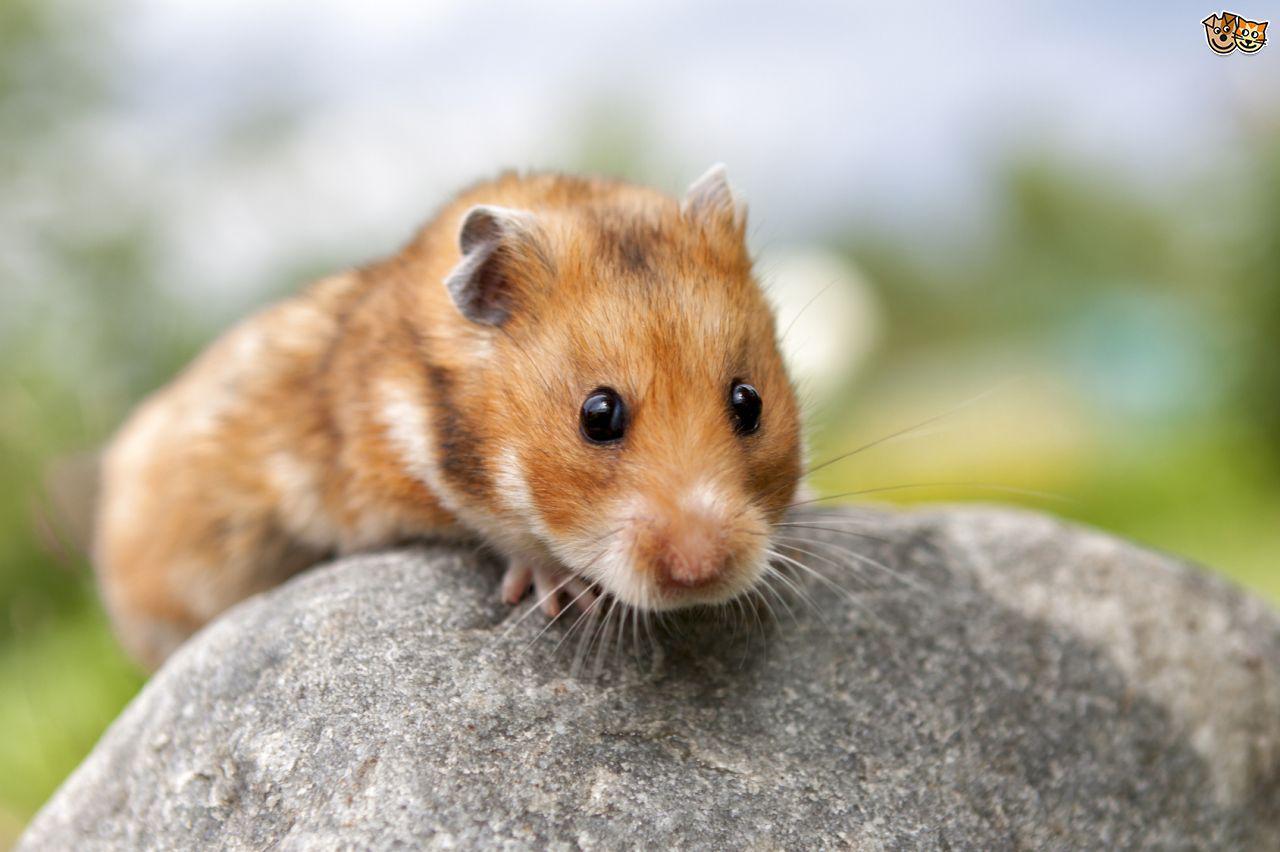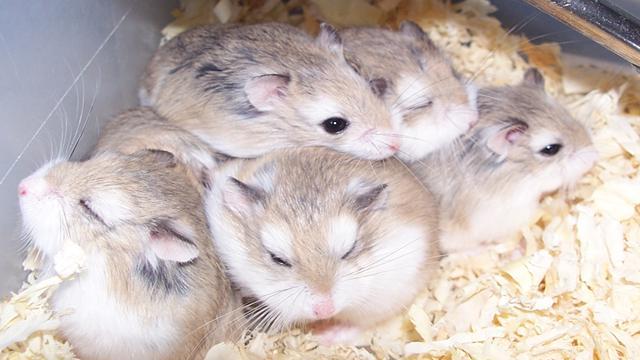The first image is the image on the left, the second image is the image on the right. For the images shown, is this caption "The right image features exactly four hamsters." true? Answer yes or no. No. 